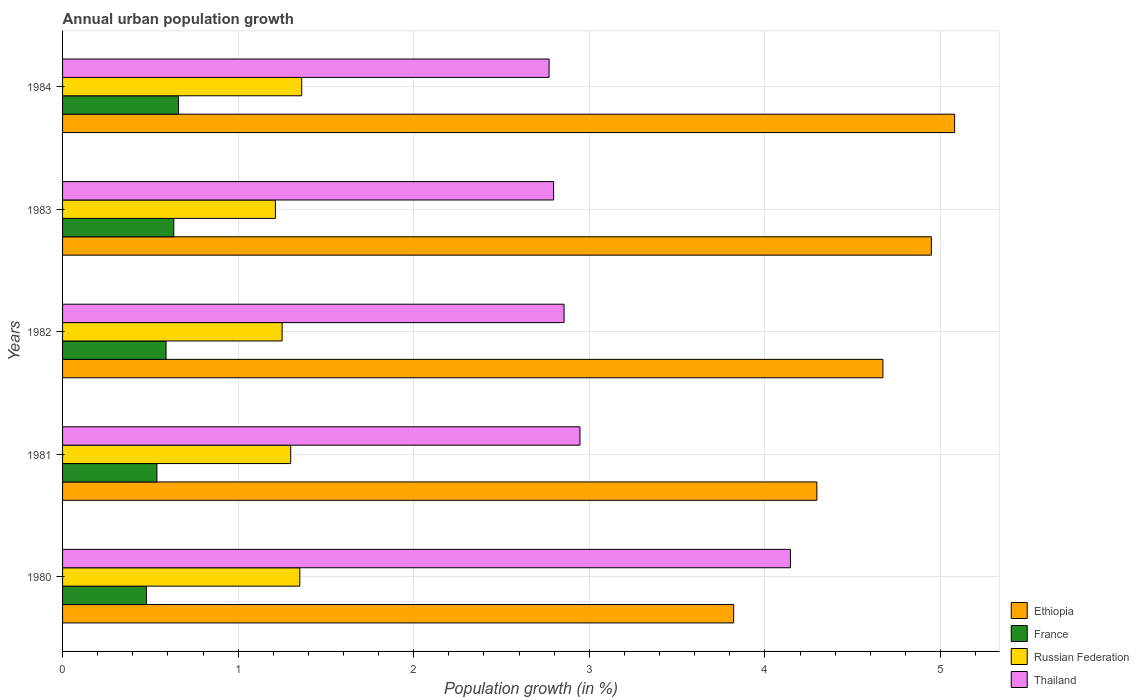How many bars are there on the 2nd tick from the top?
Ensure brevity in your answer.  4. What is the label of the 2nd group of bars from the top?
Your answer should be very brief. 1983. In how many cases, is the number of bars for a given year not equal to the number of legend labels?
Provide a short and direct response. 0. What is the percentage of urban population growth in Thailand in 1982?
Make the answer very short. 2.86. Across all years, what is the maximum percentage of urban population growth in Ethiopia?
Provide a succinct answer. 5.08. Across all years, what is the minimum percentage of urban population growth in Russian Federation?
Offer a very short reply. 1.21. In which year was the percentage of urban population growth in Thailand minimum?
Your answer should be very brief. 1984. What is the total percentage of urban population growth in France in the graph?
Keep it short and to the point. 2.9. What is the difference between the percentage of urban population growth in France in 1981 and that in 1984?
Your answer should be compact. -0.12. What is the difference between the percentage of urban population growth in France in 1981 and the percentage of urban population growth in Ethiopia in 1984?
Ensure brevity in your answer.  -4.54. What is the average percentage of urban population growth in Thailand per year?
Offer a very short reply. 3.1. In the year 1981, what is the difference between the percentage of urban population growth in Russian Federation and percentage of urban population growth in Thailand?
Offer a terse response. -1.65. What is the ratio of the percentage of urban population growth in Russian Federation in 1981 to that in 1982?
Provide a short and direct response. 1.04. Is the difference between the percentage of urban population growth in Russian Federation in 1983 and 1984 greater than the difference between the percentage of urban population growth in Thailand in 1983 and 1984?
Make the answer very short. No. What is the difference between the highest and the second highest percentage of urban population growth in Thailand?
Keep it short and to the point. 1.2. What is the difference between the highest and the lowest percentage of urban population growth in Russian Federation?
Offer a very short reply. 0.15. Is the sum of the percentage of urban population growth in France in 1980 and 1981 greater than the maximum percentage of urban population growth in Ethiopia across all years?
Ensure brevity in your answer.  No. What does the 1st bar from the top in 1983 represents?
Offer a very short reply. Thailand. What does the 1st bar from the bottom in 1980 represents?
Offer a very short reply. Ethiopia. Is it the case that in every year, the sum of the percentage of urban population growth in Ethiopia and percentage of urban population growth in France is greater than the percentage of urban population growth in Thailand?
Your answer should be very brief. Yes. How many years are there in the graph?
Keep it short and to the point. 5. Where does the legend appear in the graph?
Your response must be concise. Bottom right. What is the title of the graph?
Make the answer very short. Annual urban population growth. Does "Kyrgyz Republic" appear as one of the legend labels in the graph?
Your response must be concise. No. What is the label or title of the X-axis?
Make the answer very short. Population growth (in %). What is the Population growth (in %) of Ethiopia in 1980?
Offer a terse response. 3.82. What is the Population growth (in %) in France in 1980?
Give a very brief answer. 0.48. What is the Population growth (in %) in Russian Federation in 1980?
Provide a short and direct response. 1.35. What is the Population growth (in %) in Thailand in 1980?
Your answer should be very brief. 4.15. What is the Population growth (in %) of Ethiopia in 1981?
Provide a short and direct response. 4.3. What is the Population growth (in %) in France in 1981?
Your response must be concise. 0.54. What is the Population growth (in %) in Russian Federation in 1981?
Offer a terse response. 1.3. What is the Population growth (in %) of Thailand in 1981?
Offer a terse response. 2.95. What is the Population growth (in %) in Ethiopia in 1982?
Offer a terse response. 4.67. What is the Population growth (in %) of France in 1982?
Provide a short and direct response. 0.59. What is the Population growth (in %) in Russian Federation in 1982?
Provide a succinct answer. 1.25. What is the Population growth (in %) of Thailand in 1982?
Keep it short and to the point. 2.86. What is the Population growth (in %) in Ethiopia in 1983?
Ensure brevity in your answer.  4.95. What is the Population growth (in %) of France in 1983?
Your answer should be compact. 0.63. What is the Population growth (in %) of Russian Federation in 1983?
Make the answer very short. 1.21. What is the Population growth (in %) in Thailand in 1983?
Your answer should be compact. 2.8. What is the Population growth (in %) in Ethiopia in 1984?
Your response must be concise. 5.08. What is the Population growth (in %) of France in 1984?
Offer a very short reply. 0.66. What is the Population growth (in %) of Russian Federation in 1984?
Your answer should be compact. 1.36. What is the Population growth (in %) in Thailand in 1984?
Keep it short and to the point. 2.77. Across all years, what is the maximum Population growth (in %) of Ethiopia?
Your answer should be very brief. 5.08. Across all years, what is the maximum Population growth (in %) of France?
Your answer should be compact. 0.66. Across all years, what is the maximum Population growth (in %) in Russian Federation?
Your response must be concise. 1.36. Across all years, what is the maximum Population growth (in %) in Thailand?
Keep it short and to the point. 4.15. Across all years, what is the minimum Population growth (in %) of Ethiopia?
Your response must be concise. 3.82. Across all years, what is the minimum Population growth (in %) of France?
Ensure brevity in your answer.  0.48. Across all years, what is the minimum Population growth (in %) in Russian Federation?
Your answer should be compact. 1.21. Across all years, what is the minimum Population growth (in %) of Thailand?
Your response must be concise. 2.77. What is the total Population growth (in %) in Ethiopia in the graph?
Your answer should be compact. 22.82. What is the total Population growth (in %) of France in the graph?
Make the answer very short. 2.9. What is the total Population growth (in %) of Russian Federation in the graph?
Your response must be concise. 6.47. What is the total Population growth (in %) in Thailand in the graph?
Offer a terse response. 15.52. What is the difference between the Population growth (in %) in Ethiopia in 1980 and that in 1981?
Offer a very short reply. -0.47. What is the difference between the Population growth (in %) in France in 1980 and that in 1981?
Provide a short and direct response. -0.06. What is the difference between the Population growth (in %) in Russian Federation in 1980 and that in 1981?
Give a very brief answer. 0.05. What is the difference between the Population growth (in %) in Thailand in 1980 and that in 1981?
Offer a very short reply. 1.2. What is the difference between the Population growth (in %) of Ethiopia in 1980 and that in 1982?
Offer a very short reply. -0.85. What is the difference between the Population growth (in %) in France in 1980 and that in 1982?
Keep it short and to the point. -0.11. What is the difference between the Population growth (in %) in Russian Federation in 1980 and that in 1982?
Offer a terse response. 0.1. What is the difference between the Population growth (in %) in Thailand in 1980 and that in 1982?
Make the answer very short. 1.29. What is the difference between the Population growth (in %) in Ethiopia in 1980 and that in 1983?
Provide a short and direct response. -1.13. What is the difference between the Population growth (in %) of France in 1980 and that in 1983?
Provide a short and direct response. -0.16. What is the difference between the Population growth (in %) of Russian Federation in 1980 and that in 1983?
Offer a terse response. 0.14. What is the difference between the Population growth (in %) in Thailand in 1980 and that in 1983?
Make the answer very short. 1.35. What is the difference between the Population growth (in %) in Ethiopia in 1980 and that in 1984?
Make the answer very short. -1.26. What is the difference between the Population growth (in %) of France in 1980 and that in 1984?
Make the answer very short. -0.18. What is the difference between the Population growth (in %) of Russian Federation in 1980 and that in 1984?
Provide a short and direct response. -0.01. What is the difference between the Population growth (in %) of Thailand in 1980 and that in 1984?
Make the answer very short. 1.37. What is the difference between the Population growth (in %) in Ethiopia in 1981 and that in 1982?
Give a very brief answer. -0.38. What is the difference between the Population growth (in %) of France in 1981 and that in 1982?
Offer a very short reply. -0.05. What is the difference between the Population growth (in %) in Russian Federation in 1981 and that in 1982?
Provide a short and direct response. 0.05. What is the difference between the Population growth (in %) of Thailand in 1981 and that in 1982?
Make the answer very short. 0.09. What is the difference between the Population growth (in %) in Ethiopia in 1981 and that in 1983?
Offer a terse response. -0.65. What is the difference between the Population growth (in %) in France in 1981 and that in 1983?
Offer a very short reply. -0.1. What is the difference between the Population growth (in %) in Russian Federation in 1981 and that in 1983?
Keep it short and to the point. 0.09. What is the difference between the Population growth (in %) in Thailand in 1981 and that in 1983?
Your answer should be very brief. 0.15. What is the difference between the Population growth (in %) of Ethiopia in 1981 and that in 1984?
Keep it short and to the point. -0.78. What is the difference between the Population growth (in %) of France in 1981 and that in 1984?
Your answer should be very brief. -0.12. What is the difference between the Population growth (in %) of Russian Federation in 1981 and that in 1984?
Your response must be concise. -0.06. What is the difference between the Population growth (in %) of Thailand in 1981 and that in 1984?
Ensure brevity in your answer.  0.18. What is the difference between the Population growth (in %) in Ethiopia in 1982 and that in 1983?
Ensure brevity in your answer.  -0.28. What is the difference between the Population growth (in %) in France in 1982 and that in 1983?
Give a very brief answer. -0.04. What is the difference between the Population growth (in %) of Russian Federation in 1982 and that in 1983?
Give a very brief answer. 0.04. What is the difference between the Population growth (in %) in Thailand in 1982 and that in 1983?
Keep it short and to the point. 0.06. What is the difference between the Population growth (in %) of Ethiopia in 1982 and that in 1984?
Keep it short and to the point. -0.41. What is the difference between the Population growth (in %) of France in 1982 and that in 1984?
Your answer should be compact. -0.07. What is the difference between the Population growth (in %) of Russian Federation in 1982 and that in 1984?
Offer a terse response. -0.11. What is the difference between the Population growth (in %) in Thailand in 1982 and that in 1984?
Make the answer very short. 0.09. What is the difference between the Population growth (in %) of Ethiopia in 1983 and that in 1984?
Your answer should be compact. -0.13. What is the difference between the Population growth (in %) of France in 1983 and that in 1984?
Make the answer very short. -0.03. What is the difference between the Population growth (in %) of Russian Federation in 1983 and that in 1984?
Ensure brevity in your answer.  -0.15. What is the difference between the Population growth (in %) in Thailand in 1983 and that in 1984?
Keep it short and to the point. 0.03. What is the difference between the Population growth (in %) in Ethiopia in 1980 and the Population growth (in %) in France in 1981?
Offer a terse response. 3.28. What is the difference between the Population growth (in %) of Ethiopia in 1980 and the Population growth (in %) of Russian Federation in 1981?
Your response must be concise. 2.52. What is the difference between the Population growth (in %) of Ethiopia in 1980 and the Population growth (in %) of Thailand in 1981?
Make the answer very short. 0.88. What is the difference between the Population growth (in %) in France in 1980 and the Population growth (in %) in Russian Federation in 1981?
Make the answer very short. -0.82. What is the difference between the Population growth (in %) in France in 1980 and the Population growth (in %) in Thailand in 1981?
Provide a short and direct response. -2.47. What is the difference between the Population growth (in %) in Russian Federation in 1980 and the Population growth (in %) in Thailand in 1981?
Give a very brief answer. -1.6. What is the difference between the Population growth (in %) in Ethiopia in 1980 and the Population growth (in %) in France in 1982?
Offer a very short reply. 3.23. What is the difference between the Population growth (in %) of Ethiopia in 1980 and the Population growth (in %) of Russian Federation in 1982?
Your answer should be very brief. 2.57. What is the difference between the Population growth (in %) of Ethiopia in 1980 and the Population growth (in %) of Thailand in 1982?
Give a very brief answer. 0.97. What is the difference between the Population growth (in %) of France in 1980 and the Population growth (in %) of Russian Federation in 1982?
Your response must be concise. -0.77. What is the difference between the Population growth (in %) in France in 1980 and the Population growth (in %) in Thailand in 1982?
Keep it short and to the point. -2.38. What is the difference between the Population growth (in %) of Russian Federation in 1980 and the Population growth (in %) of Thailand in 1982?
Offer a very short reply. -1.5. What is the difference between the Population growth (in %) in Ethiopia in 1980 and the Population growth (in %) in France in 1983?
Offer a very short reply. 3.19. What is the difference between the Population growth (in %) in Ethiopia in 1980 and the Population growth (in %) in Russian Federation in 1983?
Provide a succinct answer. 2.61. What is the difference between the Population growth (in %) of Ethiopia in 1980 and the Population growth (in %) of Thailand in 1983?
Your answer should be compact. 1.03. What is the difference between the Population growth (in %) of France in 1980 and the Population growth (in %) of Russian Federation in 1983?
Your response must be concise. -0.73. What is the difference between the Population growth (in %) of France in 1980 and the Population growth (in %) of Thailand in 1983?
Give a very brief answer. -2.32. What is the difference between the Population growth (in %) in Russian Federation in 1980 and the Population growth (in %) in Thailand in 1983?
Offer a very short reply. -1.45. What is the difference between the Population growth (in %) in Ethiopia in 1980 and the Population growth (in %) in France in 1984?
Your answer should be very brief. 3.16. What is the difference between the Population growth (in %) of Ethiopia in 1980 and the Population growth (in %) of Russian Federation in 1984?
Your response must be concise. 2.46. What is the difference between the Population growth (in %) in Ethiopia in 1980 and the Population growth (in %) in Thailand in 1984?
Make the answer very short. 1.05. What is the difference between the Population growth (in %) of France in 1980 and the Population growth (in %) of Russian Federation in 1984?
Offer a very short reply. -0.88. What is the difference between the Population growth (in %) in France in 1980 and the Population growth (in %) in Thailand in 1984?
Give a very brief answer. -2.29. What is the difference between the Population growth (in %) of Russian Federation in 1980 and the Population growth (in %) of Thailand in 1984?
Your answer should be compact. -1.42. What is the difference between the Population growth (in %) of Ethiopia in 1981 and the Population growth (in %) of France in 1982?
Keep it short and to the point. 3.71. What is the difference between the Population growth (in %) in Ethiopia in 1981 and the Population growth (in %) in Russian Federation in 1982?
Offer a very short reply. 3.05. What is the difference between the Population growth (in %) in Ethiopia in 1981 and the Population growth (in %) in Thailand in 1982?
Your response must be concise. 1.44. What is the difference between the Population growth (in %) in France in 1981 and the Population growth (in %) in Russian Federation in 1982?
Offer a terse response. -0.71. What is the difference between the Population growth (in %) in France in 1981 and the Population growth (in %) in Thailand in 1982?
Provide a succinct answer. -2.32. What is the difference between the Population growth (in %) in Russian Federation in 1981 and the Population growth (in %) in Thailand in 1982?
Offer a terse response. -1.56. What is the difference between the Population growth (in %) in Ethiopia in 1981 and the Population growth (in %) in France in 1983?
Your answer should be very brief. 3.66. What is the difference between the Population growth (in %) of Ethiopia in 1981 and the Population growth (in %) of Russian Federation in 1983?
Your answer should be very brief. 3.08. What is the difference between the Population growth (in %) in Ethiopia in 1981 and the Population growth (in %) in Thailand in 1983?
Your answer should be very brief. 1.5. What is the difference between the Population growth (in %) of France in 1981 and the Population growth (in %) of Russian Federation in 1983?
Your answer should be very brief. -0.68. What is the difference between the Population growth (in %) in France in 1981 and the Population growth (in %) in Thailand in 1983?
Your answer should be compact. -2.26. What is the difference between the Population growth (in %) in Russian Federation in 1981 and the Population growth (in %) in Thailand in 1983?
Your answer should be compact. -1.5. What is the difference between the Population growth (in %) of Ethiopia in 1981 and the Population growth (in %) of France in 1984?
Keep it short and to the point. 3.64. What is the difference between the Population growth (in %) in Ethiopia in 1981 and the Population growth (in %) in Russian Federation in 1984?
Your response must be concise. 2.93. What is the difference between the Population growth (in %) of Ethiopia in 1981 and the Population growth (in %) of Thailand in 1984?
Provide a succinct answer. 1.52. What is the difference between the Population growth (in %) of France in 1981 and the Population growth (in %) of Russian Federation in 1984?
Provide a short and direct response. -0.82. What is the difference between the Population growth (in %) of France in 1981 and the Population growth (in %) of Thailand in 1984?
Your response must be concise. -2.23. What is the difference between the Population growth (in %) of Russian Federation in 1981 and the Population growth (in %) of Thailand in 1984?
Provide a short and direct response. -1.47. What is the difference between the Population growth (in %) of Ethiopia in 1982 and the Population growth (in %) of France in 1983?
Make the answer very short. 4.04. What is the difference between the Population growth (in %) of Ethiopia in 1982 and the Population growth (in %) of Russian Federation in 1983?
Ensure brevity in your answer.  3.46. What is the difference between the Population growth (in %) in Ethiopia in 1982 and the Population growth (in %) in Thailand in 1983?
Offer a terse response. 1.88. What is the difference between the Population growth (in %) in France in 1982 and the Population growth (in %) in Russian Federation in 1983?
Ensure brevity in your answer.  -0.62. What is the difference between the Population growth (in %) of France in 1982 and the Population growth (in %) of Thailand in 1983?
Your answer should be very brief. -2.21. What is the difference between the Population growth (in %) of Russian Federation in 1982 and the Population growth (in %) of Thailand in 1983?
Make the answer very short. -1.55. What is the difference between the Population growth (in %) of Ethiopia in 1982 and the Population growth (in %) of France in 1984?
Offer a very short reply. 4.01. What is the difference between the Population growth (in %) of Ethiopia in 1982 and the Population growth (in %) of Russian Federation in 1984?
Provide a short and direct response. 3.31. What is the difference between the Population growth (in %) of Ethiopia in 1982 and the Population growth (in %) of Thailand in 1984?
Offer a very short reply. 1.9. What is the difference between the Population growth (in %) in France in 1982 and the Population growth (in %) in Russian Federation in 1984?
Give a very brief answer. -0.77. What is the difference between the Population growth (in %) in France in 1982 and the Population growth (in %) in Thailand in 1984?
Offer a terse response. -2.18. What is the difference between the Population growth (in %) in Russian Federation in 1982 and the Population growth (in %) in Thailand in 1984?
Offer a very short reply. -1.52. What is the difference between the Population growth (in %) of Ethiopia in 1983 and the Population growth (in %) of France in 1984?
Ensure brevity in your answer.  4.29. What is the difference between the Population growth (in %) in Ethiopia in 1983 and the Population growth (in %) in Russian Federation in 1984?
Offer a terse response. 3.59. What is the difference between the Population growth (in %) in Ethiopia in 1983 and the Population growth (in %) in Thailand in 1984?
Your answer should be compact. 2.18. What is the difference between the Population growth (in %) in France in 1983 and the Population growth (in %) in Russian Federation in 1984?
Your answer should be compact. -0.73. What is the difference between the Population growth (in %) in France in 1983 and the Population growth (in %) in Thailand in 1984?
Your answer should be compact. -2.14. What is the difference between the Population growth (in %) in Russian Federation in 1983 and the Population growth (in %) in Thailand in 1984?
Give a very brief answer. -1.56. What is the average Population growth (in %) of Ethiopia per year?
Give a very brief answer. 4.56. What is the average Population growth (in %) of France per year?
Keep it short and to the point. 0.58. What is the average Population growth (in %) of Russian Federation per year?
Provide a short and direct response. 1.29. What is the average Population growth (in %) in Thailand per year?
Keep it short and to the point. 3.1. In the year 1980, what is the difference between the Population growth (in %) of Ethiopia and Population growth (in %) of France?
Make the answer very short. 3.34. In the year 1980, what is the difference between the Population growth (in %) in Ethiopia and Population growth (in %) in Russian Federation?
Offer a very short reply. 2.47. In the year 1980, what is the difference between the Population growth (in %) in Ethiopia and Population growth (in %) in Thailand?
Provide a short and direct response. -0.32. In the year 1980, what is the difference between the Population growth (in %) of France and Population growth (in %) of Russian Federation?
Your answer should be compact. -0.87. In the year 1980, what is the difference between the Population growth (in %) of France and Population growth (in %) of Thailand?
Your answer should be very brief. -3.67. In the year 1980, what is the difference between the Population growth (in %) in Russian Federation and Population growth (in %) in Thailand?
Make the answer very short. -2.79. In the year 1981, what is the difference between the Population growth (in %) of Ethiopia and Population growth (in %) of France?
Make the answer very short. 3.76. In the year 1981, what is the difference between the Population growth (in %) of Ethiopia and Population growth (in %) of Russian Federation?
Your answer should be very brief. 3. In the year 1981, what is the difference between the Population growth (in %) in Ethiopia and Population growth (in %) in Thailand?
Provide a short and direct response. 1.35. In the year 1981, what is the difference between the Population growth (in %) in France and Population growth (in %) in Russian Federation?
Your answer should be compact. -0.76. In the year 1981, what is the difference between the Population growth (in %) in France and Population growth (in %) in Thailand?
Offer a very short reply. -2.41. In the year 1981, what is the difference between the Population growth (in %) in Russian Federation and Population growth (in %) in Thailand?
Offer a very short reply. -1.65. In the year 1982, what is the difference between the Population growth (in %) of Ethiopia and Population growth (in %) of France?
Provide a succinct answer. 4.08. In the year 1982, what is the difference between the Population growth (in %) in Ethiopia and Population growth (in %) in Russian Federation?
Ensure brevity in your answer.  3.42. In the year 1982, what is the difference between the Population growth (in %) of Ethiopia and Population growth (in %) of Thailand?
Give a very brief answer. 1.82. In the year 1982, what is the difference between the Population growth (in %) in France and Population growth (in %) in Russian Federation?
Provide a short and direct response. -0.66. In the year 1982, what is the difference between the Population growth (in %) in France and Population growth (in %) in Thailand?
Your answer should be very brief. -2.27. In the year 1982, what is the difference between the Population growth (in %) in Russian Federation and Population growth (in %) in Thailand?
Provide a short and direct response. -1.61. In the year 1983, what is the difference between the Population growth (in %) of Ethiopia and Population growth (in %) of France?
Your response must be concise. 4.31. In the year 1983, what is the difference between the Population growth (in %) in Ethiopia and Population growth (in %) in Russian Federation?
Your answer should be compact. 3.74. In the year 1983, what is the difference between the Population growth (in %) in Ethiopia and Population growth (in %) in Thailand?
Your response must be concise. 2.15. In the year 1983, what is the difference between the Population growth (in %) in France and Population growth (in %) in Russian Federation?
Offer a very short reply. -0.58. In the year 1983, what is the difference between the Population growth (in %) in France and Population growth (in %) in Thailand?
Provide a short and direct response. -2.16. In the year 1983, what is the difference between the Population growth (in %) of Russian Federation and Population growth (in %) of Thailand?
Offer a very short reply. -1.58. In the year 1984, what is the difference between the Population growth (in %) of Ethiopia and Population growth (in %) of France?
Your answer should be very brief. 4.42. In the year 1984, what is the difference between the Population growth (in %) of Ethiopia and Population growth (in %) of Russian Federation?
Give a very brief answer. 3.72. In the year 1984, what is the difference between the Population growth (in %) of Ethiopia and Population growth (in %) of Thailand?
Provide a short and direct response. 2.31. In the year 1984, what is the difference between the Population growth (in %) in France and Population growth (in %) in Russian Federation?
Provide a short and direct response. -0.7. In the year 1984, what is the difference between the Population growth (in %) in France and Population growth (in %) in Thailand?
Provide a succinct answer. -2.11. In the year 1984, what is the difference between the Population growth (in %) in Russian Federation and Population growth (in %) in Thailand?
Provide a short and direct response. -1.41. What is the ratio of the Population growth (in %) of Ethiopia in 1980 to that in 1981?
Give a very brief answer. 0.89. What is the ratio of the Population growth (in %) of France in 1980 to that in 1981?
Keep it short and to the point. 0.89. What is the ratio of the Population growth (in %) in Russian Federation in 1980 to that in 1981?
Your response must be concise. 1.04. What is the ratio of the Population growth (in %) of Thailand in 1980 to that in 1981?
Make the answer very short. 1.41. What is the ratio of the Population growth (in %) of Ethiopia in 1980 to that in 1982?
Keep it short and to the point. 0.82. What is the ratio of the Population growth (in %) of France in 1980 to that in 1982?
Keep it short and to the point. 0.81. What is the ratio of the Population growth (in %) in Russian Federation in 1980 to that in 1982?
Keep it short and to the point. 1.08. What is the ratio of the Population growth (in %) in Thailand in 1980 to that in 1982?
Offer a very short reply. 1.45. What is the ratio of the Population growth (in %) of Ethiopia in 1980 to that in 1983?
Give a very brief answer. 0.77. What is the ratio of the Population growth (in %) in France in 1980 to that in 1983?
Keep it short and to the point. 0.75. What is the ratio of the Population growth (in %) in Russian Federation in 1980 to that in 1983?
Ensure brevity in your answer.  1.11. What is the ratio of the Population growth (in %) in Thailand in 1980 to that in 1983?
Ensure brevity in your answer.  1.48. What is the ratio of the Population growth (in %) of Ethiopia in 1980 to that in 1984?
Provide a succinct answer. 0.75. What is the ratio of the Population growth (in %) in France in 1980 to that in 1984?
Offer a terse response. 0.72. What is the ratio of the Population growth (in %) of Russian Federation in 1980 to that in 1984?
Offer a very short reply. 0.99. What is the ratio of the Population growth (in %) in Thailand in 1980 to that in 1984?
Ensure brevity in your answer.  1.5. What is the ratio of the Population growth (in %) of Ethiopia in 1981 to that in 1982?
Ensure brevity in your answer.  0.92. What is the ratio of the Population growth (in %) in France in 1981 to that in 1982?
Your answer should be compact. 0.91. What is the ratio of the Population growth (in %) of Russian Federation in 1981 to that in 1982?
Provide a short and direct response. 1.04. What is the ratio of the Population growth (in %) of Thailand in 1981 to that in 1982?
Ensure brevity in your answer.  1.03. What is the ratio of the Population growth (in %) of Ethiopia in 1981 to that in 1983?
Give a very brief answer. 0.87. What is the ratio of the Population growth (in %) of France in 1981 to that in 1983?
Keep it short and to the point. 0.85. What is the ratio of the Population growth (in %) of Russian Federation in 1981 to that in 1983?
Your response must be concise. 1.07. What is the ratio of the Population growth (in %) of Thailand in 1981 to that in 1983?
Keep it short and to the point. 1.05. What is the ratio of the Population growth (in %) in Ethiopia in 1981 to that in 1984?
Your response must be concise. 0.85. What is the ratio of the Population growth (in %) of France in 1981 to that in 1984?
Provide a short and direct response. 0.81. What is the ratio of the Population growth (in %) of Russian Federation in 1981 to that in 1984?
Offer a terse response. 0.95. What is the ratio of the Population growth (in %) in Thailand in 1981 to that in 1984?
Offer a very short reply. 1.06. What is the ratio of the Population growth (in %) of Ethiopia in 1982 to that in 1983?
Ensure brevity in your answer.  0.94. What is the ratio of the Population growth (in %) of France in 1982 to that in 1983?
Ensure brevity in your answer.  0.93. What is the ratio of the Population growth (in %) of Russian Federation in 1982 to that in 1983?
Offer a very short reply. 1.03. What is the ratio of the Population growth (in %) in Thailand in 1982 to that in 1983?
Your answer should be very brief. 1.02. What is the ratio of the Population growth (in %) in Ethiopia in 1982 to that in 1984?
Make the answer very short. 0.92. What is the ratio of the Population growth (in %) in France in 1982 to that in 1984?
Your answer should be very brief. 0.89. What is the ratio of the Population growth (in %) of Russian Federation in 1982 to that in 1984?
Make the answer very short. 0.92. What is the ratio of the Population growth (in %) of Thailand in 1982 to that in 1984?
Your answer should be compact. 1.03. What is the ratio of the Population growth (in %) in Ethiopia in 1983 to that in 1984?
Offer a terse response. 0.97. What is the ratio of the Population growth (in %) of Russian Federation in 1983 to that in 1984?
Keep it short and to the point. 0.89. What is the ratio of the Population growth (in %) in Thailand in 1983 to that in 1984?
Offer a very short reply. 1.01. What is the difference between the highest and the second highest Population growth (in %) in Ethiopia?
Provide a succinct answer. 0.13. What is the difference between the highest and the second highest Population growth (in %) of France?
Offer a very short reply. 0.03. What is the difference between the highest and the second highest Population growth (in %) in Russian Federation?
Ensure brevity in your answer.  0.01. What is the difference between the highest and the second highest Population growth (in %) in Thailand?
Your answer should be compact. 1.2. What is the difference between the highest and the lowest Population growth (in %) of Ethiopia?
Provide a short and direct response. 1.26. What is the difference between the highest and the lowest Population growth (in %) in France?
Make the answer very short. 0.18. What is the difference between the highest and the lowest Population growth (in %) in Russian Federation?
Provide a succinct answer. 0.15. What is the difference between the highest and the lowest Population growth (in %) of Thailand?
Keep it short and to the point. 1.37. 